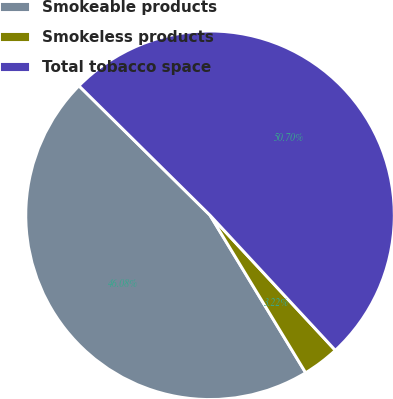Convert chart. <chart><loc_0><loc_0><loc_500><loc_500><pie_chart><fcel>Smokeable products<fcel>Smokeless products<fcel>Total tobacco space<nl><fcel>46.08%<fcel>3.22%<fcel>50.69%<nl></chart> 